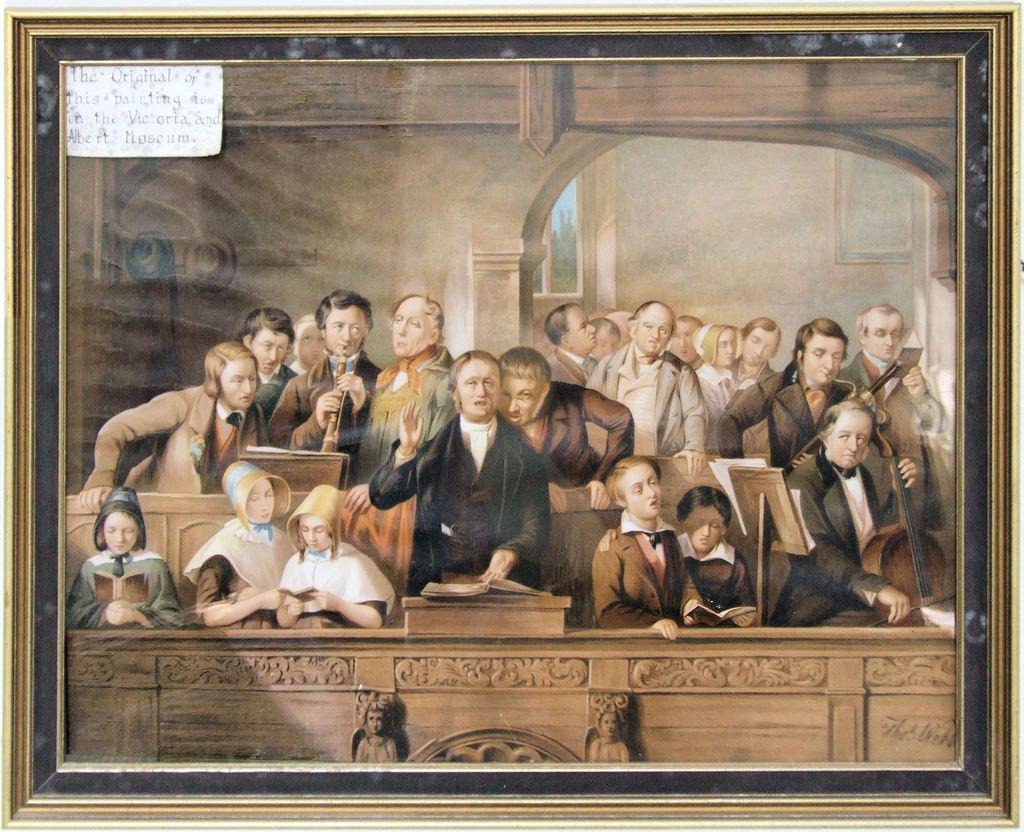What can be seen in the photo frame? There is a group of people, musical instruments, and books in the photo frame. Can you describe the objects in the photo frame? There are some objects in the photo frame, including musical instruments and books. What might the people in the photo frame be doing? It is possible that the group of people in the photo frame are playing musical instruments or reading books. How much profit did the hen make in the photo frame? There is no hen present in the photo frame, so it is not possible to determine any profit made. 